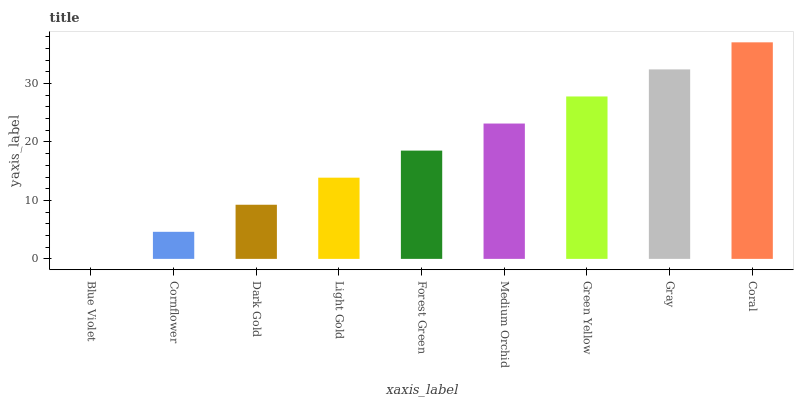Is Blue Violet the minimum?
Answer yes or no. Yes. Is Coral the maximum?
Answer yes or no. Yes. Is Cornflower the minimum?
Answer yes or no. No. Is Cornflower the maximum?
Answer yes or no. No. Is Cornflower greater than Blue Violet?
Answer yes or no. Yes. Is Blue Violet less than Cornflower?
Answer yes or no. Yes. Is Blue Violet greater than Cornflower?
Answer yes or no. No. Is Cornflower less than Blue Violet?
Answer yes or no. No. Is Forest Green the high median?
Answer yes or no. Yes. Is Forest Green the low median?
Answer yes or no. Yes. Is Green Yellow the high median?
Answer yes or no. No. Is Light Gold the low median?
Answer yes or no. No. 